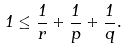<formula> <loc_0><loc_0><loc_500><loc_500>1 \leq \frac { 1 } { r } + \frac { 1 } { p } + \frac { 1 } { q } .</formula> 